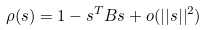Convert formula to latex. <formula><loc_0><loc_0><loc_500><loc_500>\rho ( s ) = 1 - s ^ { T } B s + o ( | | s | | ^ { 2 } )</formula> 